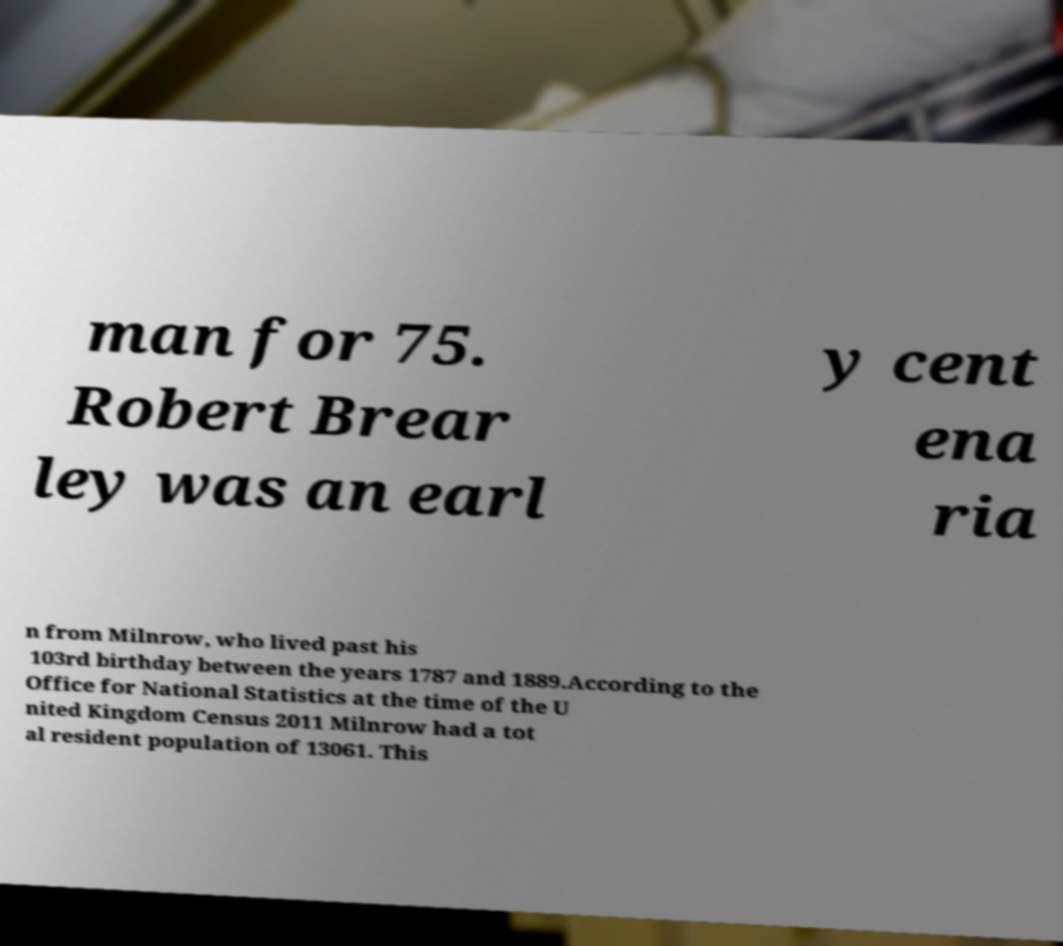Can you accurately transcribe the text from the provided image for me? man for 75. Robert Brear ley was an earl y cent ena ria n from Milnrow, who lived past his 103rd birthday between the years 1787 and 1889.According to the Office for National Statistics at the time of the U nited Kingdom Census 2011 Milnrow had a tot al resident population of 13061. This 